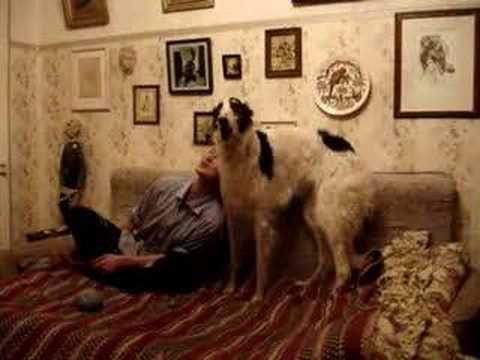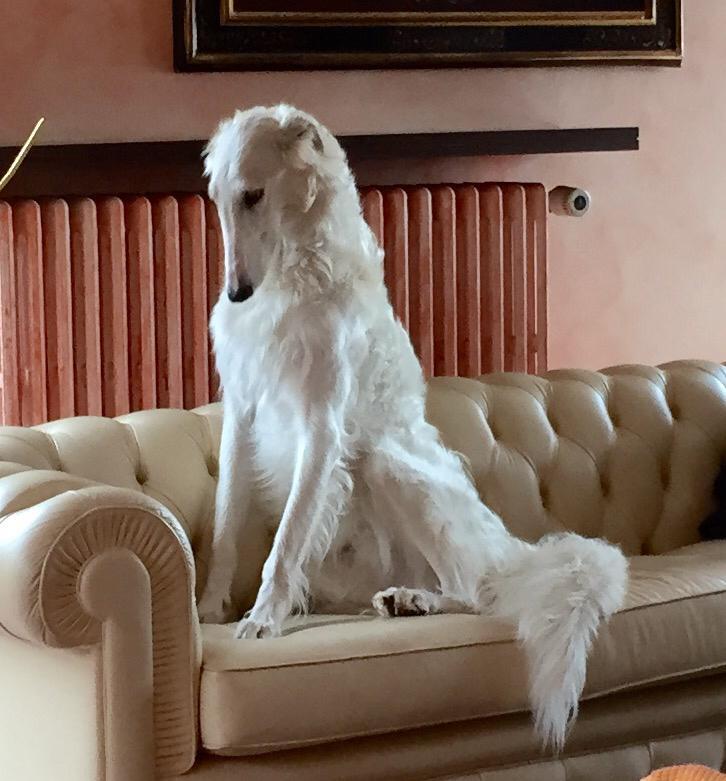The first image is the image on the left, the second image is the image on the right. Examine the images to the left and right. Is the description "One image shows at least one dog reclining on a dark sofa with its muzzle pointed upward and its mouth slightly opened." accurate? Answer yes or no. No. 